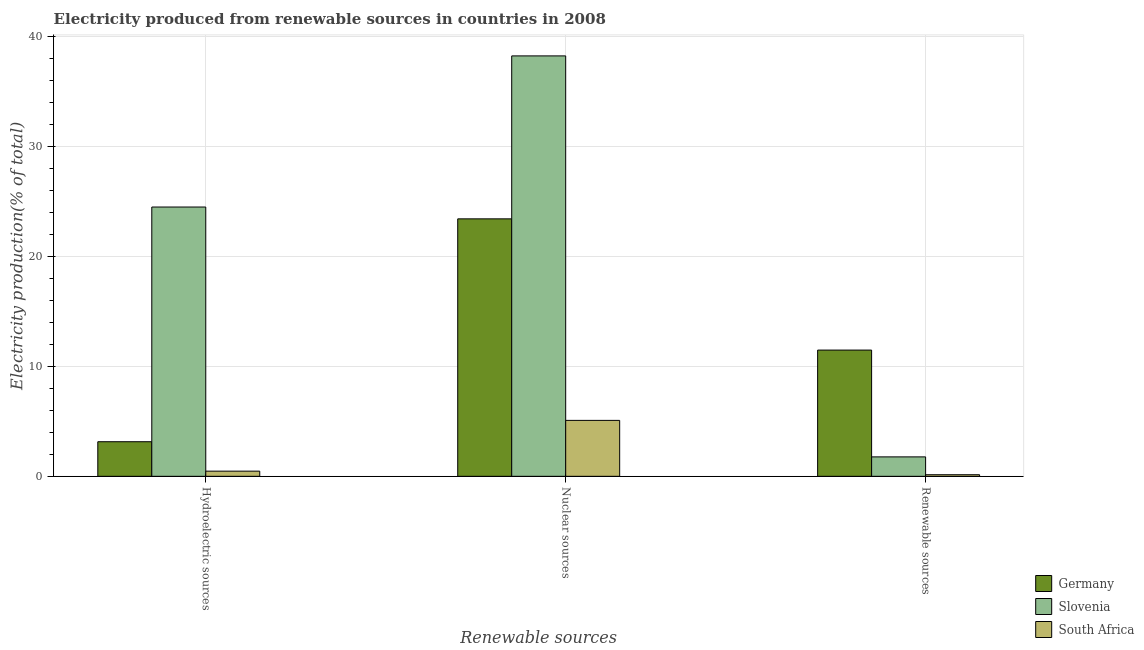How many different coloured bars are there?
Your answer should be very brief. 3. Are the number of bars on each tick of the X-axis equal?
Provide a short and direct response. Yes. How many bars are there on the 2nd tick from the right?
Your answer should be compact. 3. What is the label of the 2nd group of bars from the left?
Offer a terse response. Nuclear sources. What is the percentage of electricity produced by hydroelectric sources in South Africa?
Provide a short and direct response. 0.47. Across all countries, what is the maximum percentage of electricity produced by hydroelectric sources?
Provide a short and direct response. 24.5. Across all countries, what is the minimum percentage of electricity produced by nuclear sources?
Ensure brevity in your answer.  5.09. In which country was the percentage of electricity produced by hydroelectric sources minimum?
Give a very brief answer. South Africa. What is the total percentage of electricity produced by nuclear sources in the graph?
Provide a succinct answer. 66.77. What is the difference between the percentage of electricity produced by nuclear sources in Germany and that in South Africa?
Make the answer very short. 18.34. What is the difference between the percentage of electricity produced by hydroelectric sources in South Africa and the percentage of electricity produced by nuclear sources in Germany?
Your response must be concise. -22.96. What is the average percentage of electricity produced by nuclear sources per country?
Your response must be concise. 22.26. What is the difference between the percentage of electricity produced by hydroelectric sources and percentage of electricity produced by renewable sources in Germany?
Give a very brief answer. -8.34. What is the ratio of the percentage of electricity produced by hydroelectric sources in Germany to that in Slovenia?
Offer a terse response. 0.13. Is the percentage of electricity produced by renewable sources in Slovenia less than that in South Africa?
Offer a terse response. No. Is the difference between the percentage of electricity produced by hydroelectric sources in South Africa and Germany greater than the difference between the percentage of electricity produced by renewable sources in South Africa and Germany?
Give a very brief answer. Yes. What is the difference between the highest and the second highest percentage of electricity produced by renewable sources?
Your response must be concise. 9.72. What is the difference between the highest and the lowest percentage of electricity produced by renewable sources?
Offer a very short reply. 11.34. In how many countries, is the percentage of electricity produced by nuclear sources greater than the average percentage of electricity produced by nuclear sources taken over all countries?
Ensure brevity in your answer.  2. Is the sum of the percentage of electricity produced by hydroelectric sources in Germany and Slovenia greater than the maximum percentage of electricity produced by renewable sources across all countries?
Make the answer very short. Yes. What does the 2nd bar from the left in Hydroelectric sources represents?
Offer a terse response. Slovenia. What does the 3rd bar from the right in Hydroelectric sources represents?
Offer a terse response. Germany. Is it the case that in every country, the sum of the percentage of electricity produced by hydroelectric sources and percentage of electricity produced by nuclear sources is greater than the percentage of electricity produced by renewable sources?
Give a very brief answer. Yes. How many bars are there?
Your answer should be very brief. 9. What is the difference between two consecutive major ticks on the Y-axis?
Your response must be concise. 10. Where does the legend appear in the graph?
Provide a short and direct response. Bottom right. How many legend labels are there?
Make the answer very short. 3. What is the title of the graph?
Your answer should be compact. Electricity produced from renewable sources in countries in 2008. What is the label or title of the X-axis?
Provide a short and direct response. Renewable sources. What is the Electricity production(% of total) of Germany in Hydroelectric sources?
Keep it short and to the point. 3.15. What is the Electricity production(% of total) in Slovenia in Hydroelectric sources?
Ensure brevity in your answer.  24.5. What is the Electricity production(% of total) in South Africa in Hydroelectric sources?
Provide a succinct answer. 0.47. What is the Electricity production(% of total) of Germany in Nuclear sources?
Give a very brief answer. 23.43. What is the Electricity production(% of total) of Slovenia in Nuclear sources?
Your response must be concise. 38.25. What is the Electricity production(% of total) of South Africa in Nuclear sources?
Keep it short and to the point. 5.09. What is the Electricity production(% of total) in Germany in Renewable sources?
Make the answer very short. 11.49. What is the Electricity production(% of total) of Slovenia in Renewable sources?
Your response must be concise. 1.77. What is the Electricity production(% of total) of South Africa in Renewable sources?
Your answer should be very brief. 0.14. Across all Renewable sources, what is the maximum Electricity production(% of total) in Germany?
Give a very brief answer. 23.43. Across all Renewable sources, what is the maximum Electricity production(% of total) of Slovenia?
Your answer should be compact. 38.25. Across all Renewable sources, what is the maximum Electricity production(% of total) of South Africa?
Provide a succinct answer. 5.09. Across all Renewable sources, what is the minimum Electricity production(% of total) of Germany?
Keep it short and to the point. 3.15. Across all Renewable sources, what is the minimum Electricity production(% of total) in Slovenia?
Your answer should be very brief. 1.77. Across all Renewable sources, what is the minimum Electricity production(% of total) in South Africa?
Your response must be concise. 0.14. What is the total Electricity production(% of total) of Germany in the graph?
Offer a very short reply. 38.06. What is the total Electricity production(% of total) of Slovenia in the graph?
Provide a short and direct response. 64.52. What is the total Electricity production(% of total) in South Africa in the graph?
Give a very brief answer. 5.7. What is the difference between the Electricity production(% of total) of Germany in Hydroelectric sources and that in Nuclear sources?
Your answer should be compact. -20.28. What is the difference between the Electricity production(% of total) of Slovenia in Hydroelectric sources and that in Nuclear sources?
Ensure brevity in your answer.  -13.75. What is the difference between the Electricity production(% of total) in South Africa in Hydroelectric sources and that in Nuclear sources?
Provide a succinct answer. -4.62. What is the difference between the Electricity production(% of total) of Germany in Hydroelectric sources and that in Renewable sources?
Give a very brief answer. -8.34. What is the difference between the Electricity production(% of total) of Slovenia in Hydroelectric sources and that in Renewable sources?
Provide a short and direct response. 22.73. What is the difference between the Electricity production(% of total) of South Africa in Hydroelectric sources and that in Renewable sources?
Your answer should be compact. 0.33. What is the difference between the Electricity production(% of total) of Germany in Nuclear sources and that in Renewable sources?
Keep it short and to the point. 11.94. What is the difference between the Electricity production(% of total) in Slovenia in Nuclear sources and that in Renewable sources?
Your answer should be very brief. 36.48. What is the difference between the Electricity production(% of total) in South Africa in Nuclear sources and that in Renewable sources?
Your response must be concise. 4.94. What is the difference between the Electricity production(% of total) of Germany in Hydroelectric sources and the Electricity production(% of total) of Slovenia in Nuclear sources?
Your answer should be very brief. -35.11. What is the difference between the Electricity production(% of total) of Germany in Hydroelectric sources and the Electricity production(% of total) of South Africa in Nuclear sources?
Make the answer very short. -1.94. What is the difference between the Electricity production(% of total) in Slovenia in Hydroelectric sources and the Electricity production(% of total) in South Africa in Nuclear sources?
Make the answer very short. 19.41. What is the difference between the Electricity production(% of total) of Germany in Hydroelectric sources and the Electricity production(% of total) of Slovenia in Renewable sources?
Ensure brevity in your answer.  1.38. What is the difference between the Electricity production(% of total) of Germany in Hydroelectric sources and the Electricity production(% of total) of South Africa in Renewable sources?
Your response must be concise. 3. What is the difference between the Electricity production(% of total) in Slovenia in Hydroelectric sources and the Electricity production(% of total) in South Africa in Renewable sources?
Provide a succinct answer. 24.36. What is the difference between the Electricity production(% of total) in Germany in Nuclear sources and the Electricity production(% of total) in Slovenia in Renewable sources?
Keep it short and to the point. 21.66. What is the difference between the Electricity production(% of total) of Germany in Nuclear sources and the Electricity production(% of total) of South Africa in Renewable sources?
Offer a very short reply. 23.28. What is the difference between the Electricity production(% of total) in Slovenia in Nuclear sources and the Electricity production(% of total) in South Africa in Renewable sources?
Your answer should be compact. 38.11. What is the average Electricity production(% of total) in Germany per Renewable sources?
Offer a very short reply. 12.69. What is the average Electricity production(% of total) in Slovenia per Renewable sources?
Your answer should be compact. 21.51. What is the average Electricity production(% of total) of South Africa per Renewable sources?
Keep it short and to the point. 1.9. What is the difference between the Electricity production(% of total) in Germany and Electricity production(% of total) in Slovenia in Hydroelectric sources?
Make the answer very short. -21.35. What is the difference between the Electricity production(% of total) of Germany and Electricity production(% of total) of South Africa in Hydroelectric sources?
Offer a terse response. 2.68. What is the difference between the Electricity production(% of total) in Slovenia and Electricity production(% of total) in South Africa in Hydroelectric sources?
Your response must be concise. 24.03. What is the difference between the Electricity production(% of total) in Germany and Electricity production(% of total) in Slovenia in Nuclear sources?
Provide a short and direct response. -14.83. What is the difference between the Electricity production(% of total) of Germany and Electricity production(% of total) of South Africa in Nuclear sources?
Provide a short and direct response. 18.34. What is the difference between the Electricity production(% of total) of Slovenia and Electricity production(% of total) of South Africa in Nuclear sources?
Make the answer very short. 33.16. What is the difference between the Electricity production(% of total) of Germany and Electricity production(% of total) of Slovenia in Renewable sources?
Provide a short and direct response. 9.72. What is the difference between the Electricity production(% of total) of Germany and Electricity production(% of total) of South Africa in Renewable sources?
Offer a terse response. 11.34. What is the difference between the Electricity production(% of total) of Slovenia and Electricity production(% of total) of South Africa in Renewable sources?
Provide a short and direct response. 1.62. What is the ratio of the Electricity production(% of total) in Germany in Hydroelectric sources to that in Nuclear sources?
Keep it short and to the point. 0.13. What is the ratio of the Electricity production(% of total) of Slovenia in Hydroelectric sources to that in Nuclear sources?
Ensure brevity in your answer.  0.64. What is the ratio of the Electricity production(% of total) in South Africa in Hydroelectric sources to that in Nuclear sources?
Offer a terse response. 0.09. What is the ratio of the Electricity production(% of total) of Germany in Hydroelectric sources to that in Renewable sources?
Give a very brief answer. 0.27. What is the ratio of the Electricity production(% of total) of Slovenia in Hydroelectric sources to that in Renewable sources?
Give a very brief answer. 13.86. What is the ratio of the Electricity production(% of total) in South Africa in Hydroelectric sources to that in Renewable sources?
Ensure brevity in your answer.  3.26. What is the ratio of the Electricity production(% of total) in Germany in Nuclear sources to that in Renewable sources?
Your response must be concise. 2.04. What is the ratio of the Electricity production(% of total) in Slovenia in Nuclear sources to that in Renewable sources?
Ensure brevity in your answer.  21.63. What is the ratio of the Electricity production(% of total) in South Africa in Nuclear sources to that in Renewable sources?
Offer a very short reply. 35.24. What is the difference between the highest and the second highest Electricity production(% of total) of Germany?
Make the answer very short. 11.94. What is the difference between the highest and the second highest Electricity production(% of total) in Slovenia?
Offer a very short reply. 13.75. What is the difference between the highest and the second highest Electricity production(% of total) of South Africa?
Give a very brief answer. 4.62. What is the difference between the highest and the lowest Electricity production(% of total) of Germany?
Keep it short and to the point. 20.28. What is the difference between the highest and the lowest Electricity production(% of total) of Slovenia?
Provide a succinct answer. 36.48. What is the difference between the highest and the lowest Electricity production(% of total) in South Africa?
Offer a terse response. 4.94. 